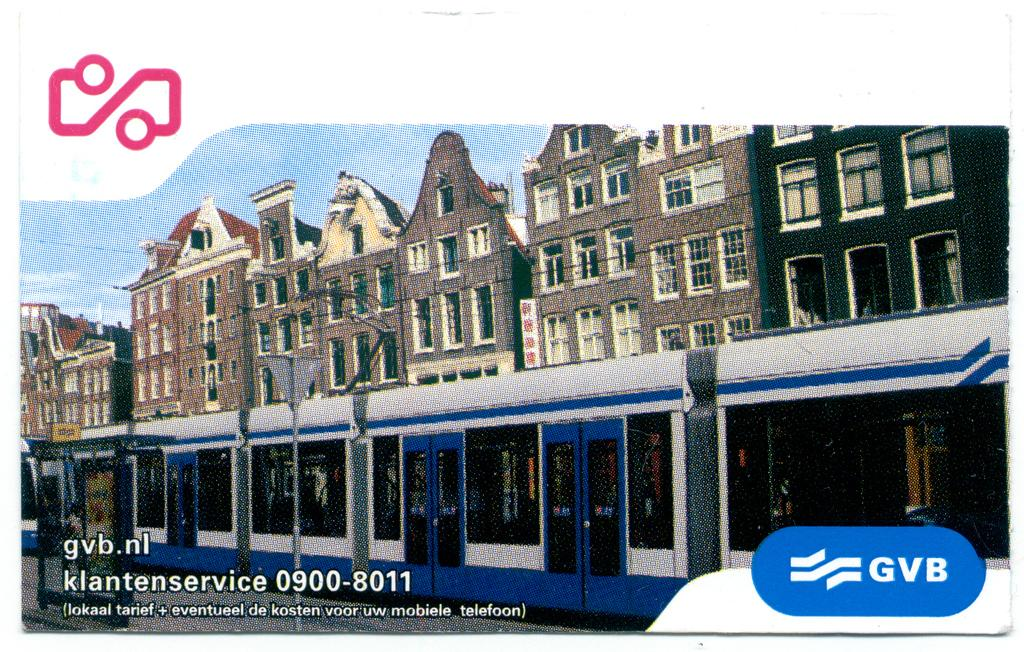What can be inferred about the image based on the provided fact? The image appears to be edited. What type of structure is present in the image? There is a building in the image. What mode of transportation can be seen in the image? There is a train in the image. What object is present in the image that might be used for support or attachment? There is a pole in the image. What part of the natural environment is visible in the image? The sky is visible in the image. What type of cloth is being used to say good-bye in the image? There is no cloth or good-bye gesture present in the image. What need does the train have in the image? The train does not have any specific need in the image; it is simply a mode of transportation that is present. 